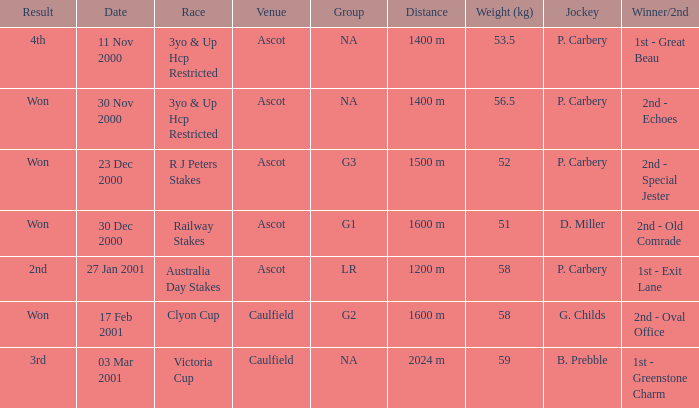What was the conclusion of the railway stakes race? Won. 